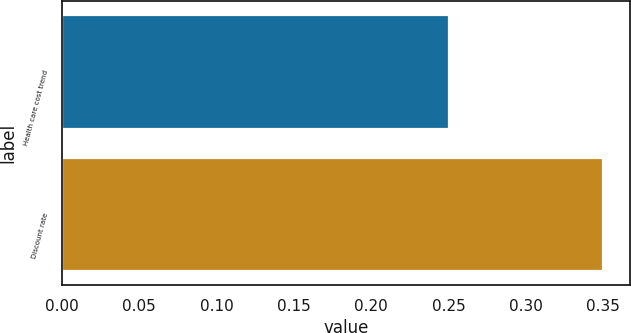Convert chart to OTSL. <chart><loc_0><loc_0><loc_500><loc_500><bar_chart><fcel>Health care cost trend<fcel>Discount rate<nl><fcel>0.25<fcel>0.35<nl></chart> 